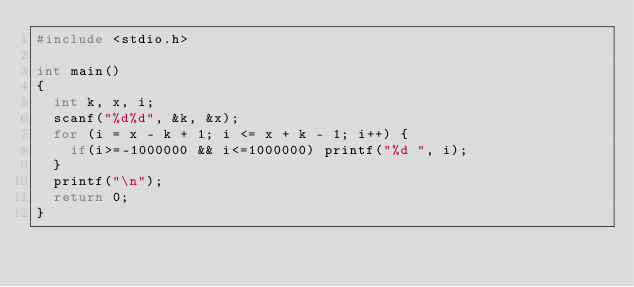<code> <loc_0><loc_0><loc_500><loc_500><_C_>#include <stdio.h>

int main()
{
  int k, x, i;
  scanf("%d%d", &k, &x);
  for (i = x - k + 1; i <= x + k - 1; i++) {
    if(i>=-1000000 && i<=1000000) printf("%d ", i);
  }
  printf("\n");
  return 0;
}</code> 